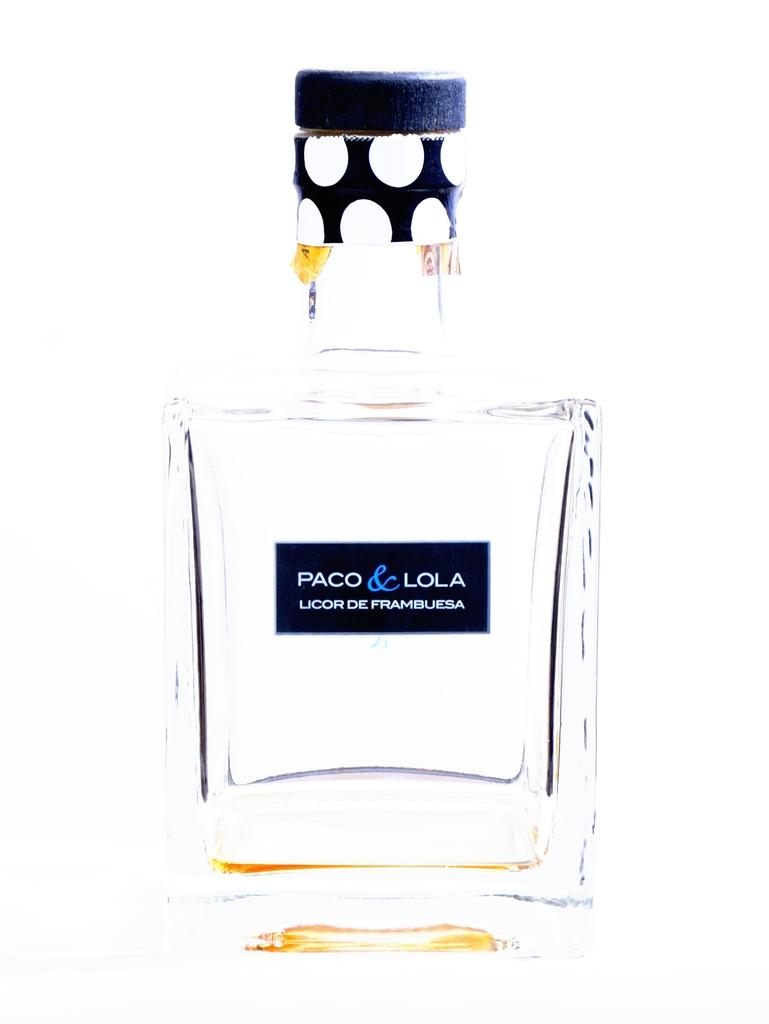<image>
Write a terse but informative summary of the picture. A close up view of a perfume bottle displaying the name Paco & Lola. 